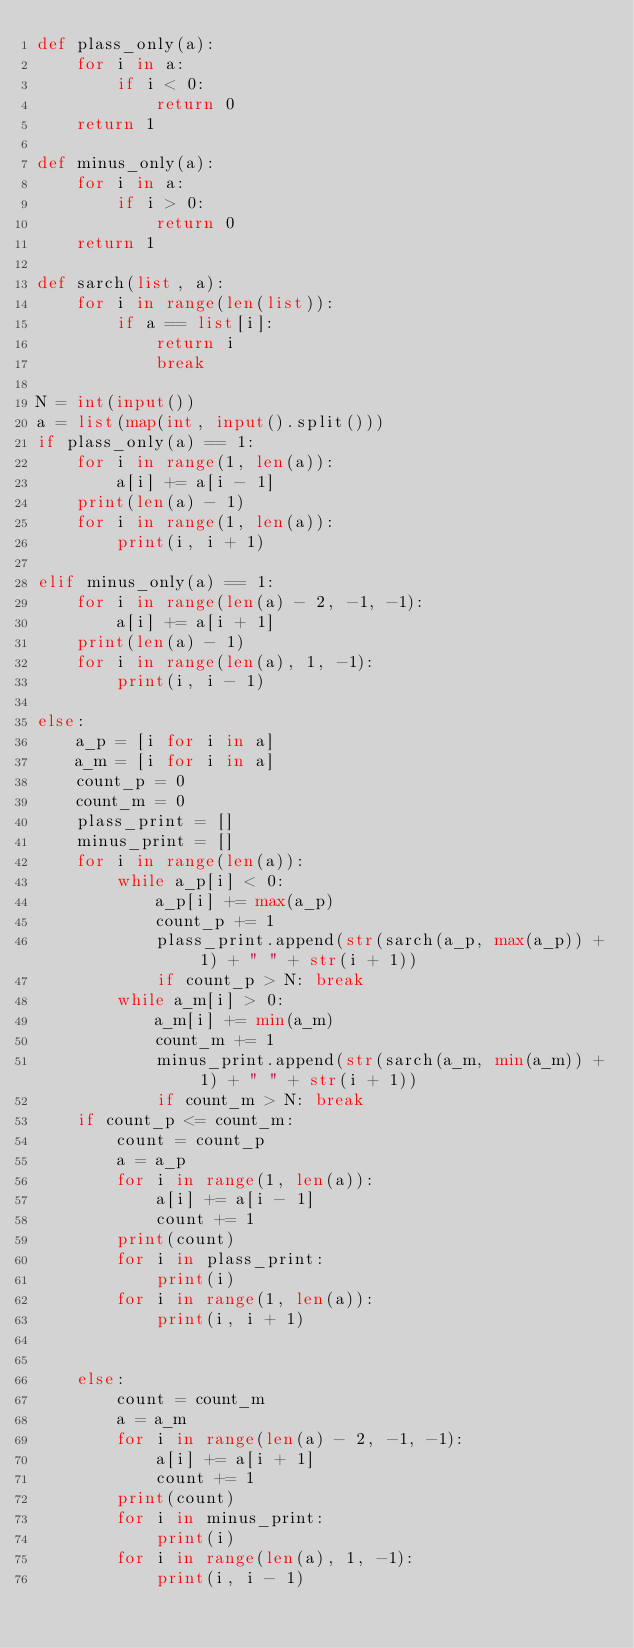<code> <loc_0><loc_0><loc_500><loc_500><_Python_>def plass_only(a):
    for i in a:
        if i < 0:
            return 0
    return 1

def minus_only(a):
    for i in a:
        if i > 0:
            return 0
    return 1

def sarch(list, a):
    for i in range(len(list)):
        if a == list[i]:
            return i
            break

N = int(input())
a = list(map(int, input().split()))
if plass_only(a) == 1:
    for i in range(1, len(a)):
        a[i] += a[i - 1]
    print(len(a) - 1)
    for i in range(1, len(a)):
        print(i, i + 1)

elif minus_only(a) == 1:
    for i in range(len(a) - 2, -1, -1):
        a[i] += a[i + 1]
    print(len(a) - 1)
    for i in range(len(a), 1, -1):
        print(i, i - 1)

else:
    a_p = [i for i in a]
    a_m = [i for i in a]
    count_p = 0
    count_m = 0
    plass_print = []
    minus_print = []
    for i in range(len(a)):
        while a_p[i] < 0:
            a_p[i] += max(a_p)
            count_p += 1
            plass_print.append(str(sarch(a_p, max(a_p)) + 1) + " " + str(i + 1))
            if count_p > N: break
        while a_m[i] > 0:
            a_m[i] += min(a_m)
            count_m += 1
            minus_print.append(str(sarch(a_m, min(a_m)) + 1) + " " + str(i + 1))
            if count_m > N: break
    if count_p <= count_m:
        count = count_p
        a = a_p
        for i in range(1, len(a)):
            a[i] += a[i - 1]
            count += 1
        print(count)
        for i in plass_print:
            print(i)
        for i in range(1, len(a)):
            print(i, i + 1)

        
    else:
        count = count_m
        a = a_m
        for i in range(len(a) - 2, -1, -1):
            a[i] += a[i + 1]
            count += 1
        print(count)
        for i in minus_print:
            print(i)
        for i in range(len(a), 1, -1):
            print(i, i - 1)
        
</code> 